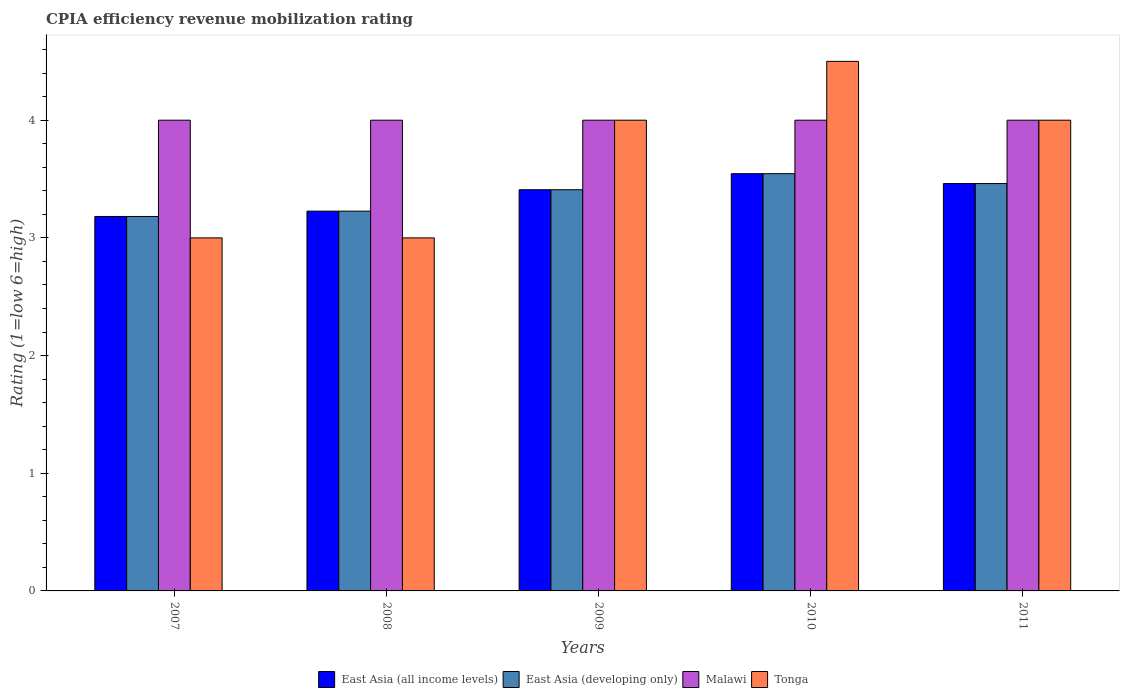How many different coloured bars are there?
Offer a very short reply. 4. How many groups of bars are there?
Offer a terse response. 5. How many bars are there on the 3rd tick from the left?
Offer a terse response. 4. What is the label of the 4th group of bars from the left?
Keep it short and to the point. 2010. In how many cases, is the number of bars for a given year not equal to the number of legend labels?
Make the answer very short. 0. Across all years, what is the maximum CPIA rating in East Asia (developing only)?
Your answer should be very brief. 3.55. Across all years, what is the minimum CPIA rating in Malawi?
Your answer should be very brief. 4. In which year was the CPIA rating in Tonga maximum?
Give a very brief answer. 2010. What is the total CPIA rating in East Asia (all income levels) in the graph?
Your answer should be compact. 16.83. What is the difference between the CPIA rating in East Asia (all income levels) in 2011 and the CPIA rating in Malawi in 2010?
Your answer should be very brief. -0.54. What is the average CPIA rating in East Asia (developing only) per year?
Your response must be concise. 3.37. In the year 2009, what is the difference between the CPIA rating in East Asia (all income levels) and CPIA rating in Tonga?
Make the answer very short. -0.59. Is the CPIA rating in East Asia (developing only) in 2008 less than that in 2009?
Give a very brief answer. Yes. What is the difference between the highest and the second highest CPIA rating in East Asia (all income levels)?
Provide a short and direct response. 0.08. What is the difference between the highest and the lowest CPIA rating in Tonga?
Ensure brevity in your answer.  1.5. In how many years, is the CPIA rating in Malawi greater than the average CPIA rating in Malawi taken over all years?
Make the answer very short. 0. What does the 4th bar from the left in 2011 represents?
Offer a terse response. Tonga. What does the 3rd bar from the right in 2011 represents?
Your response must be concise. East Asia (developing only). Is it the case that in every year, the sum of the CPIA rating in Malawi and CPIA rating in East Asia (developing only) is greater than the CPIA rating in Tonga?
Keep it short and to the point. Yes. How many bars are there?
Provide a succinct answer. 20. How many years are there in the graph?
Keep it short and to the point. 5. What is the difference between two consecutive major ticks on the Y-axis?
Make the answer very short. 1. Are the values on the major ticks of Y-axis written in scientific E-notation?
Provide a short and direct response. No. Does the graph contain grids?
Offer a terse response. No. Where does the legend appear in the graph?
Provide a succinct answer. Bottom center. What is the title of the graph?
Keep it short and to the point. CPIA efficiency revenue mobilization rating. What is the label or title of the Y-axis?
Your answer should be compact. Rating (1=low 6=high). What is the Rating (1=low 6=high) in East Asia (all income levels) in 2007?
Make the answer very short. 3.18. What is the Rating (1=low 6=high) in East Asia (developing only) in 2007?
Give a very brief answer. 3.18. What is the Rating (1=low 6=high) of Tonga in 2007?
Make the answer very short. 3. What is the Rating (1=low 6=high) of East Asia (all income levels) in 2008?
Ensure brevity in your answer.  3.23. What is the Rating (1=low 6=high) in East Asia (developing only) in 2008?
Offer a terse response. 3.23. What is the Rating (1=low 6=high) of Tonga in 2008?
Keep it short and to the point. 3. What is the Rating (1=low 6=high) of East Asia (all income levels) in 2009?
Give a very brief answer. 3.41. What is the Rating (1=low 6=high) of East Asia (developing only) in 2009?
Provide a short and direct response. 3.41. What is the Rating (1=low 6=high) in East Asia (all income levels) in 2010?
Provide a succinct answer. 3.55. What is the Rating (1=low 6=high) in East Asia (developing only) in 2010?
Your answer should be compact. 3.55. What is the Rating (1=low 6=high) in Tonga in 2010?
Provide a succinct answer. 4.5. What is the Rating (1=low 6=high) in East Asia (all income levels) in 2011?
Your answer should be very brief. 3.46. What is the Rating (1=low 6=high) of East Asia (developing only) in 2011?
Your answer should be very brief. 3.46. Across all years, what is the maximum Rating (1=low 6=high) in East Asia (all income levels)?
Keep it short and to the point. 3.55. Across all years, what is the maximum Rating (1=low 6=high) in East Asia (developing only)?
Provide a succinct answer. 3.55. Across all years, what is the maximum Rating (1=low 6=high) of Tonga?
Your answer should be compact. 4.5. Across all years, what is the minimum Rating (1=low 6=high) of East Asia (all income levels)?
Offer a very short reply. 3.18. Across all years, what is the minimum Rating (1=low 6=high) of East Asia (developing only)?
Make the answer very short. 3.18. What is the total Rating (1=low 6=high) of East Asia (all income levels) in the graph?
Provide a short and direct response. 16.83. What is the total Rating (1=low 6=high) in East Asia (developing only) in the graph?
Give a very brief answer. 16.83. What is the total Rating (1=low 6=high) of Malawi in the graph?
Provide a succinct answer. 20. What is the total Rating (1=low 6=high) of Tonga in the graph?
Provide a succinct answer. 18.5. What is the difference between the Rating (1=low 6=high) in East Asia (all income levels) in 2007 and that in 2008?
Provide a short and direct response. -0.05. What is the difference between the Rating (1=low 6=high) of East Asia (developing only) in 2007 and that in 2008?
Offer a very short reply. -0.05. What is the difference between the Rating (1=low 6=high) of Tonga in 2007 and that in 2008?
Provide a succinct answer. 0. What is the difference between the Rating (1=low 6=high) of East Asia (all income levels) in 2007 and that in 2009?
Your answer should be compact. -0.23. What is the difference between the Rating (1=low 6=high) in East Asia (developing only) in 2007 and that in 2009?
Your answer should be compact. -0.23. What is the difference between the Rating (1=low 6=high) of Malawi in 2007 and that in 2009?
Ensure brevity in your answer.  0. What is the difference between the Rating (1=low 6=high) in Tonga in 2007 and that in 2009?
Offer a very short reply. -1. What is the difference between the Rating (1=low 6=high) of East Asia (all income levels) in 2007 and that in 2010?
Your answer should be compact. -0.36. What is the difference between the Rating (1=low 6=high) in East Asia (developing only) in 2007 and that in 2010?
Your answer should be compact. -0.36. What is the difference between the Rating (1=low 6=high) in Tonga in 2007 and that in 2010?
Your answer should be compact. -1.5. What is the difference between the Rating (1=low 6=high) in East Asia (all income levels) in 2007 and that in 2011?
Offer a very short reply. -0.28. What is the difference between the Rating (1=low 6=high) in East Asia (developing only) in 2007 and that in 2011?
Ensure brevity in your answer.  -0.28. What is the difference between the Rating (1=low 6=high) of East Asia (all income levels) in 2008 and that in 2009?
Make the answer very short. -0.18. What is the difference between the Rating (1=low 6=high) in East Asia (developing only) in 2008 and that in 2009?
Give a very brief answer. -0.18. What is the difference between the Rating (1=low 6=high) of Tonga in 2008 and that in 2009?
Your response must be concise. -1. What is the difference between the Rating (1=low 6=high) of East Asia (all income levels) in 2008 and that in 2010?
Offer a very short reply. -0.32. What is the difference between the Rating (1=low 6=high) of East Asia (developing only) in 2008 and that in 2010?
Your answer should be compact. -0.32. What is the difference between the Rating (1=low 6=high) in Malawi in 2008 and that in 2010?
Provide a short and direct response. 0. What is the difference between the Rating (1=low 6=high) in Tonga in 2008 and that in 2010?
Provide a succinct answer. -1.5. What is the difference between the Rating (1=low 6=high) of East Asia (all income levels) in 2008 and that in 2011?
Offer a terse response. -0.23. What is the difference between the Rating (1=low 6=high) in East Asia (developing only) in 2008 and that in 2011?
Your response must be concise. -0.23. What is the difference between the Rating (1=low 6=high) in Malawi in 2008 and that in 2011?
Your answer should be very brief. 0. What is the difference between the Rating (1=low 6=high) of East Asia (all income levels) in 2009 and that in 2010?
Your response must be concise. -0.14. What is the difference between the Rating (1=low 6=high) in East Asia (developing only) in 2009 and that in 2010?
Your answer should be compact. -0.14. What is the difference between the Rating (1=low 6=high) in Malawi in 2009 and that in 2010?
Keep it short and to the point. 0. What is the difference between the Rating (1=low 6=high) of East Asia (all income levels) in 2009 and that in 2011?
Give a very brief answer. -0.05. What is the difference between the Rating (1=low 6=high) in East Asia (developing only) in 2009 and that in 2011?
Your answer should be compact. -0.05. What is the difference between the Rating (1=low 6=high) of Tonga in 2009 and that in 2011?
Your answer should be compact. 0. What is the difference between the Rating (1=low 6=high) in East Asia (all income levels) in 2010 and that in 2011?
Give a very brief answer. 0.08. What is the difference between the Rating (1=low 6=high) in East Asia (developing only) in 2010 and that in 2011?
Your response must be concise. 0.08. What is the difference between the Rating (1=low 6=high) of Tonga in 2010 and that in 2011?
Provide a short and direct response. 0.5. What is the difference between the Rating (1=low 6=high) in East Asia (all income levels) in 2007 and the Rating (1=low 6=high) in East Asia (developing only) in 2008?
Offer a terse response. -0.05. What is the difference between the Rating (1=low 6=high) in East Asia (all income levels) in 2007 and the Rating (1=low 6=high) in Malawi in 2008?
Provide a succinct answer. -0.82. What is the difference between the Rating (1=low 6=high) of East Asia (all income levels) in 2007 and the Rating (1=low 6=high) of Tonga in 2008?
Offer a very short reply. 0.18. What is the difference between the Rating (1=low 6=high) in East Asia (developing only) in 2007 and the Rating (1=low 6=high) in Malawi in 2008?
Your answer should be compact. -0.82. What is the difference between the Rating (1=low 6=high) of East Asia (developing only) in 2007 and the Rating (1=low 6=high) of Tonga in 2008?
Your answer should be compact. 0.18. What is the difference between the Rating (1=low 6=high) of Malawi in 2007 and the Rating (1=low 6=high) of Tonga in 2008?
Give a very brief answer. 1. What is the difference between the Rating (1=low 6=high) in East Asia (all income levels) in 2007 and the Rating (1=low 6=high) in East Asia (developing only) in 2009?
Provide a succinct answer. -0.23. What is the difference between the Rating (1=low 6=high) of East Asia (all income levels) in 2007 and the Rating (1=low 6=high) of Malawi in 2009?
Ensure brevity in your answer.  -0.82. What is the difference between the Rating (1=low 6=high) in East Asia (all income levels) in 2007 and the Rating (1=low 6=high) in Tonga in 2009?
Provide a short and direct response. -0.82. What is the difference between the Rating (1=low 6=high) of East Asia (developing only) in 2007 and the Rating (1=low 6=high) of Malawi in 2009?
Your response must be concise. -0.82. What is the difference between the Rating (1=low 6=high) of East Asia (developing only) in 2007 and the Rating (1=low 6=high) of Tonga in 2009?
Ensure brevity in your answer.  -0.82. What is the difference between the Rating (1=low 6=high) in Malawi in 2007 and the Rating (1=low 6=high) in Tonga in 2009?
Provide a succinct answer. 0. What is the difference between the Rating (1=low 6=high) of East Asia (all income levels) in 2007 and the Rating (1=low 6=high) of East Asia (developing only) in 2010?
Provide a short and direct response. -0.36. What is the difference between the Rating (1=low 6=high) of East Asia (all income levels) in 2007 and the Rating (1=low 6=high) of Malawi in 2010?
Your response must be concise. -0.82. What is the difference between the Rating (1=low 6=high) in East Asia (all income levels) in 2007 and the Rating (1=low 6=high) in Tonga in 2010?
Keep it short and to the point. -1.32. What is the difference between the Rating (1=low 6=high) in East Asia (developing only) in 2007 and the Rating (1=low 6=high) in Malawi in 2010?
Ensure brevity in your answer.  -0.82. What is the difference between the Rating (1=low 6=high) of East Asia (developing only) in 2007 and the Rating (1=low 6=high) of Tonga in 2010?
Your answer should be compact. -1.32. What is the difference between the Rating (1=low 6=high) in East Asia (all income levels) in 2007 and the Rating (1=low 6=high) in East Asia (developing only) in 2011?
Offer a very short reply. -0.28. What is the difference between the Rating (1=low 6=high) in East Asia (all income levels) in 2007 and the Rating (1=low 6=high) in Malawi in 2011?
Keep it short and to the point. -0.82. What is the difference between the Rating (1=low 6=high) of East Asia (all income levels) in 2007 and the Rating (1=low 6=high) of Tonga in 2011?
Your answer should be very brief. -0.82. What is the difference between the Rating (1=low 6=high) in East Asia (developing only) in 2007 and the Rating (1=low 6=high) in Malawi in 2011?
Provide a short and direct response. -0.82. What is the difference between the Rating (1=low 6=high) in East Asia (developing only) in 2007 and the Rating (1=low 6=high) in Tonga in 2011?
Make the answer very short. -0.82. What is the difference between the Rating (1=low 6=high) in East Asia (all income levels) in 2008 and the Rating (1=low 6=high) in East Asia (developing only) in 2009?
Your answer should be compact. -0.18. What is the difference between the Rating (1=low 6=high) of East Asia (all income levels) in 2008 and the Rating (1=low 6=high) of Malawi in 2009?
Provide a short and direct response. -0.77. What is the difference between the Rating (1=low 6=high) in East Asia (all income levels) in 2008 and the Rating (1=low 6=high) in Tonga in 2009?
Offer a terse response. -0.77. What is the difference between the Rating (1=low 6=high) of East Asia (developing only) in 2008 and the Rating (1=low 6=high) of Malawi in 2009?
Provide a short and direct response. -0.77. What is the difference between the Rating (1=low 6=high) in East Asia (developing only) in 2008 and the Rating (1=low 6=high) in Tonga in 2009?
Provide a short and direct response. -0.77. What is the difference between the Rating (1=low 6=high) of East Asia (all income levels) in 2008 and the Rating (1=low 6=high) of East Asia (developing only) in 2010?
Offer a very short reply. -0.32. What is the difference between the Rating (1=low 6=high) of East Asia (all income levels) in 2008 and the Rating (1=low 6=high) of Malawi in 2010?
Your answer should be very brief. -0.77. What is the difference between the Rating (1=low 6=high) in East Asia (all income levels) in 2008 and the Rating (1=low 6=high) in Tonga in 2010?
Provide a short and direct response. -1.27. What is the difference between the Rating (1=low 6=high) of East Asia (developing only) in 2008 and the Rating (1=low 6=high) of Malawi in 2010?
Keep it short and to the point. -0.77. What is the difference between the Rating (1=low 6=high) in East Asia (developing only) in 2008 and the Rating (1=low 6=high) in Tonga in 2010?
Keep it short and to the point. -1.27. What is the difference between the Rating (1=low 6=high) in Malawi in 2008 and the Rating (1=low 6=high) in Tonga in 2010?
Offer a terse response. -0.5. What is the difference between the Rating (1=low 6=high) of East Asia (all income levels) in 2008 and the Rating (1=low 6=high) of East Asia (developing only) in 2011?
Offer a terse response. -0.23. What is the difference between the Rating (1=low 6=high) in East Asia (all income levels) in 2008 and the Rating (1=low 6=high) in Malawi in 2011?
Your response must be concise. -0.77. What is the difference between the Rating (1=low 6=high) of East Asia (all income levels) in 2008 and the Rating (1=low 6=high) of Tonga in 2011?
Offer a very short reply. -0.77. What is the difference between the Rating (1=low 6=high) of East Asia (developing only) in 2008 and the Rating (1=low 6=high) of Malawi in 2011?
Your answer should be compact. -0.77. What is the difference between the Rating (1=low 6=high) in East Asia (developing only) in 2008 and the Rating (1=low 6=high) in Tonga in 2011?
Provide a succinct answer. -0.77. What is the difference between the Rating (1=low 6=high) in East Asia (all income levels) in 2009 and the Rating (1=low 6=high) in East Asia (developing only) in 2010?
Make the answer very short. -0.14. What is the difference between the Rating (1=low 6=high) of East Asia (all income levels) in 2009 and the Rating (1=low 6=high) of Malawi in 2010?
Your answer should be compact. -0.59. What is the difference between the Rating (1=low 6=high) of East Asia (all income levels) in 2009 and the Rating (1=low 6=high) of Tonga in 2010?
Your answer should be compact. -1.09. What is the difference between the Rating (1=low 6=high) of East Asia (developing only) in 2009 and the Rating (1=low 6=high) of Malawi in 2010?
Your answer should be very brief. -0.59. What is the difference between the Rating (1=low 6=high) in East Asia (developing only) in 2009 and the Rating (1=low 6=high) in Tonga in 2010?
Your response must be concise. -1.09. What is the difference between the Rating (1=low 6=high) of Malawi in 2009 and the Rating (1=low 6=high) of Tonga in 2010?
Provide a short and direct response. -0.5. What is the difference between the Rating (1=low 6=high) of East Asia (all income levels) in 2009 and the Rating (1=low 6=high) of East Asia (developing only) in 2011?
Your answer should be compact. -0.05. What is the difference between the Rating (1=low 6=high) in East Asia (all income levels) in 2009 and the Rating (1=low 6=high) in Malawi in 2011?
Offer a terse response. -0.59. What is the difference between the Rating (1=low 6=high) of East Asia (all income levels) in 2009 and the Rating (1=low 6=high) of Tonga in 2011?
Provide a succinct answer. -0.59. What is the difference between the Rating (1=low 6=high) in East Asia (developing only) in 2009 and the Rating (1=low 6=high) in Malawi in 2011?
Your answer should be compact. -0.59. What is the difference between the Rating (1=low 6=high) in East Asia (developing only) in 2009 and the Rating (1=low 6=high) in Tonga in 2011?
Your response must be concise. -0.59. What is the difference between the Rating (1=low 6=high) of Malawi in 2009 and the Rating (1=low 6=high) of Tonga in 2011?
Your answer should be compact. 0. What is the difference between the Rating (1=low 6=high) in East Asia (all income levels) in 2010 and the Rating (1=low 6=high) in East Asia (developing only) in 2011?
Make the answer very short. 0.08. What is the difference between the Rating (1=low 6=high) of East Asia (all income levels) in 2010 and the Rating (1=low 6=high) of Malawi in 2011?
Make the answer very short. -0.45. What is the difference between the Rating (1=low 6=high) in East Asia (all income levels) in 2010 and the Rating (1=low 6=high) in Tonga in 2011?
Ensure brevity in your answer.  -0.45. What is the difference between the Rating (1=low 6=high) of East Asia (developing only) in 2010 and the Rating (1=low 6=high) of Malawi in 2011?
Offer a very short reply. -0.45. What is the difference between the Rating (1=low 6=high) in East Asia (developing only) in 2010 and the Rating (1=low 6=high) in Tonga in 2011?
Ensure brevity in your answer.  -0.45. What is the difference between the Rating (1=low 6=high) in Malawi in 2010 and the Rating (1=low 6=high) in Tonga in 2011?
Provide a short and direct response. 0. What is the average Rating (1=low 6=high) of East Asia (all income levels) per year?
Your answer should be very brief. 3.37. What is the average Rating (1=low 6=high) of East Asia (developing only) per year?
Your answer should be very brief. 3.37. In the year 2007, what is the difference between the Rating (1=low 6=high) of East Asia (all income levels) and Rating (1=low 6=high) of Malawi?
Your answer should be compact. -0.82. In the year 2007, what is the difference between the Rating (1=low 6=high) of East Asia (all income levels) and Rating (1=low 6=high) of Tonga?
Provide a succinct answer. 0.18. In the year 2007, what is the difference between the Rating (1=low 6=high) in East Asia (developing only) and Rating (1=low 6=high) in Malawi?
Give a very brief answer. -0.82. In the year 2007, what is the difference between the Rating (1=low 6=high) in East Asia (developing only) and Rating (1=low 6=high) in Tonga?
Give a very brief answer. 0.18. In the year 2007, what is the difference between the Rating (1=low 6=high) in Malawi and Rating (1=low 6=high) in Tonga?
Offer a very short reply. 1. In the year 2008, what is the difference between the Rating (1=low 6=high) of East Asia (all income levels) and Rating (1=low 6=high) of Malawi?
Keep it short and to the point. -0.77. In the year 2008, what is the difference between the Rating (1=low 6=high) in East Asia (all income levels) and Rating (1=low 6=high) in Tonga?
Your answer should be compact. 0.23. In the year 2008, what is the difference between the Rating (1=low 6=high) in East Asia (developing only) and Rating (1=low 6=high) in Malawi?
Ensure brevity in your answer.  -0.77. In the year 2008, what is the difference between the Rating (1=low 6=high) of East Asia (developing only) and Rating (1=low 6=high) of Tonga?
Offer a very short reply. 0.23. In the year 2009, what is the difference between the Rating (1=low 6=high) in East Asia (all income levels) and Rating (1=low 6=high) in Malawi?
Provide a succinct answer. -0.59. In the year 2009, what is the difference between the Rating (1=low 6=high) of East Asia (all income levels) and Rating (1=low 6=high) of Tonga?
Ensure brevity in your answer.  -0.59. In the year 2009, what is the difference between the Rating (1=low 6=high) in East Asia (developing only) and Rating (1=low 6=high) in Malawi?
Your answer should be compact. -0.59. In the year 2009, what is the difference between the Rating (1=low 6=high) in East Asia (developing only) and Rating (1=low 6=high) in Tonga?
Provide a short and direct response. -0.59. In the year 2009, what is the difference between the Rating (1=low 6=high) of Malawi and Rating (1=low 6=high) of Tonga?
Your answer should be very brief. 0. In the year 2010, what is the difference between the Rating (1=low 6=high) in East Asia (all income levels) and Rating (1=low 6=high) in East Asia (developing only)?
Offer a terse response. 0. In the year 2010, what is the difference between the Rating (1=low 6=high) in East Asia (all income levels) and Rating (1=low 6=high) in Malawi?
Keep it short and to the point. -0.45. In the year 2010, what is the difference between the Rating (1=low 6=high) of East Asia (all income levels) and Rating (1=low 6=high) of Tonga?
Keep it short and to the point. -0.95. In the year 2010, what is the difference between the Rating (1=low 6=high) in East Asia (developing only) and Rating (1=low 6=high) in Malawi?
Provide a short and direct response. -0.45. In the year 2010, what is the difference between the Rating (1=low 6=high) of East Asia (developing only) and Rating (1=low 6=high) of Tonga?
Keep it short and to the point. -0.95. In the year 2010, what is the difference between the Rating (1=low 6=high) of Malawi and Rating (1=low 6=high) of Tonga?
Your response must be concise. -0.5. In the year 2011, what is the difference between the Rating (1=low 6=high) in East Asia (all income levels) and Rating (1=low 6=high) in Malawi?
Your response must be concise. -0.54. In the year 2011, what is the difference between the Rating (1=low 6=high) in East Asia (all income levels) and Rating (1=low 6=high) in Tonga?
Provide a short and direct response. -0.54. In the year 2011, what is the difference between the Rating (1=low 6=high) in East Asia (developing only) and Rating (1=low 6=high) in Malawi?
Offer a very short reply. -0.54. In the year 2011, what is the difference between the Rating (1=low 6=high) of East Asia (developing only) and Rating (1=low 6=high) of Tonga?
Give a very brief answer. -0.54. In the year 2011, what is the difference between the Rating (1=low 6=high) of Malawi and Rating (1=low 6=high) of Tonga?
Provide a short and direct response. 0. What is the ratio of the Rating (1=low 6=high) of East Asia (all income levels) in 2007 to that in 2008?
Make the answer very short. 0.99. What is the ratio of the Rating (1=low 6=high) of East Asia (developing only) in 2007 to that in 2008?
Your answer should be compact. 0.99. What is the ratio of the Rating (1=low 6=high) in East Asia (developing only) in 2007 to that in 2009?
Your response must be concise. 0.93. What is the ratio of the Rating (1=low 6=high) of Malawi in 2007 to that in 2009?
Provide a succinct answer. 1. What is the ratio of the Rating (1=low 6=high) in Tonga in 2007 to that in 2009?
Your answer should be very brief. 0.75. What is the ratio of the Rating (1=low 6=high) of East Asia (all income levels) in 2007 to that in 2010?
Keep it short and to the point. 0.9. What is the ratio of the Rating (1=low 6=high) of East Asia (developing only) in 2007 to that in 2010?
Ensure brevity in your answer.  0.9. What is the ratio of the Rating (1=low 6=high) of Tonga in 2007 to that in 2010?
Ensure brevity in your answer.  0.67. What is the ratio of the Rating (1=low 6=high) of East Asia (all income levels) in 2007 to that in 2011?
Offer a terse response. 0.92. What is the ratio of the Rating (1=low 6=high) of East Asia (developing only) in 2007 to that in 2011?
Your response must be concise. 0.92. What is the ratio of the Rating (1=low 6=high) of Tonga in 2007 to that in 2011?
Keep it short and to the point. 0.75. What is the ratio of the Rating (1=low 6=high) in East Asia (all income levels) in 2008 to that in 2009?
Provide a short and direct response. 0.95. What is the ratio of the Rating (1=low 6=high) of East Asia (developing only) in 2008 to that in 2009?
Give a very brief answer. 0.95. What is the ratio of the Rating (1=low 6=high) in Malawi in 2008 to that in 2009?
Offer a very short reply. 1. What is the ratio of the Rating (1=low 6=high) of Tonga in 2008 to that in 2009?
Your answer should be very brief. 0.75. What is the ratio of the Rating (1=low 6=high) of East Asia (all income levels) in 2008 to that in 2010?
Provide a short and direct response. 0.91. What is the ratio of the Rating (1=low 6=high) in East Asia (developing only) in 2008 to that in 2010?
Your answer should be compact. 0.91. What is the ratio of the Rating (1=low 6=high) of Malawi in 2008 to that in 2010?
Give a very brief answer. 1. What is the ratio of the Rating (1=low 6=high) in East Asia (all income levels) in 2008 to that in 2011?
Provide a succinct answer. 0.93. What is the ratio of the Rating (1=low 6=high) in East Asia (developing only) in 2008 to that in 2011?
Make the answer very short. 0.93. What is the ratio of the Rating (1=low 6=high) of East Asia (all income levels) in 2009 to that in 2010?
Offer a terse response. 0.96. What is the ratio of the Rating (1=low 6=high) in East Asia (developing only) in 2009 to that in 2010?
Ensure brevity in your answer.  0.96. What is the ratio of the Rating (1=low 6=high) in Malawi in 2009 to that in 2011?
Provide a succinct answer. 1. What is the ratio of the Rating (1=low 6=high) in East Asia (all income levels) in 2010 to that in 2011?
Provide a short and direct response. 1.02. What is the ratio of the Rating (1=low 6=high) of East Asia (developing only) in 2010 to that in 2011?
Your answer should be very brief. 1.02. What is the ratio of the Rating (1=low 6=high) of Malawi in 2010 to that in 2011?
Keep it short and to the point. 1. What is the difference between the highest and the second highest Rating (1=low 6=high) in East Asia (all income levels)?
Your answer should be compact. 0.08. What is the difference between the highest and the second highest Rating (1=low 6=high) of East Asia (developing only)?
Make the answer very short. 0.08. What is the difference between the highest and the second highest Rating (1=low 6=high) in Malawi?
Your answer should be very brief. 0. What is the difference between the highest and the lowest Rating (1=low 6=high) of East Asia (all income levels)?
Provide a succinct answer. 0.36. What is the difference between the highest and the lowest Rating (1=low 6=high) in East Asia (developing only)?
Provide a succinct answer. 0.36. 